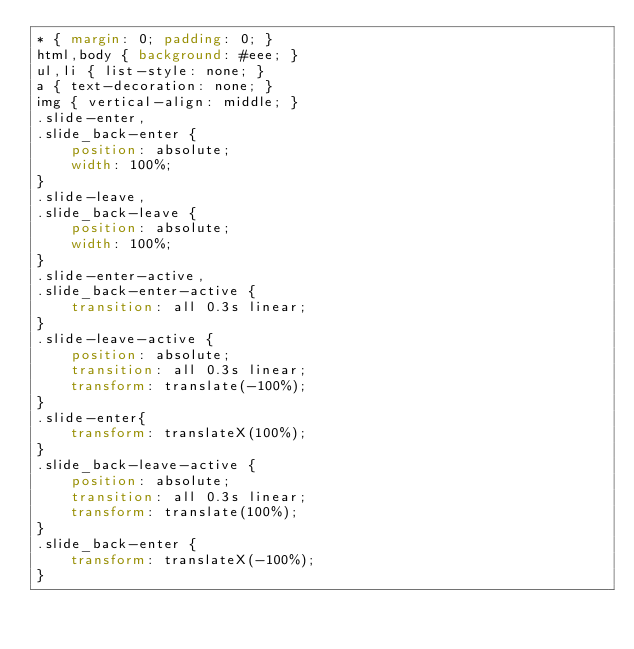Convert code to text. <code><loc_0><loc_0><loc_500><loc_500><_CSS_>* { margin: 0; padding: 0; }
html,body { background: #eee; }
ul,li { list-style: none; }
a { text-decoration: none; }
img { vertical-align: middle; }
.slide-enter,
.slide_back-enter {
    position: absolute;
    width: 100%;
}
.slide-leave,
.slide_back-leave {
    position: absolute;
    width: 100%;
}
.slide-enter-active,
.slide_back-enter-active {
    transition: all 0.3s linear;
}
.slide-leave-active {
    position: absolute;
    transition: all 0.3s linear;
    transform: translate(-100%);
}
.slide-enter{
    transform: translateX(100%);
}
.slide_back-leave-active {
    position: absolute;
    transition: all 0.3s linear;
    transform: translate(100%);
}
.slide_back-enter {
    transform: translateX(-100%);
}</code> 